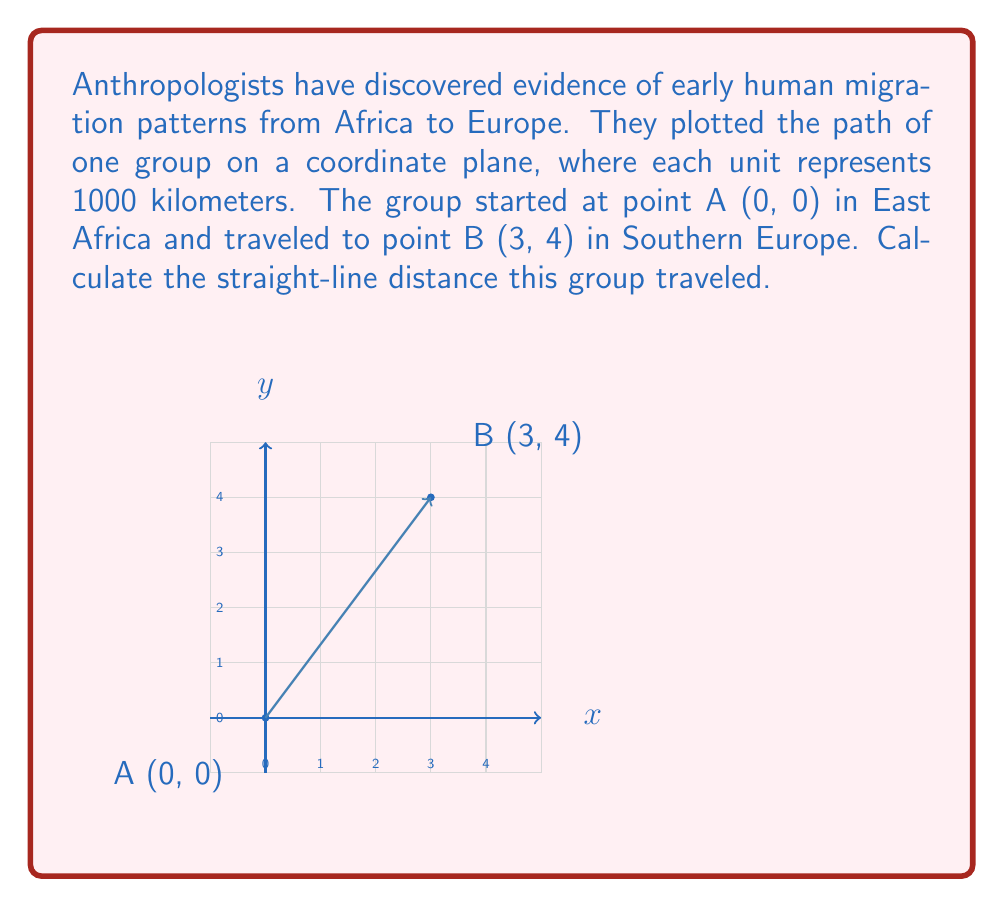Can you answer this question? To find the straight-line distance between two points on a coordinate plane, we can use the distance formula, which is derived from the Pythagorean theorem:

$$d = \sqrt{(x_2 - x_1)^2 + (y_2 - y_1)^2}$$

Where $(x_1, y_1)$ is the starting point and $(x_2, y_2)$ is the ending point.

Given:
- Starting point A: $(x_1, y_1) = (0, 0)$
- Ending point B: $(x_2, y_2) = (3, 4)$

Let's plug these values into the formula:

$$\begin{align}
d &= \sqrt{(x_2 - x_1)^2 + (y_2 - y_1)^2} \\
&= \sqrt{(3 - 0)^2 + (4 - 0)^2} \\
&= \sqrt{3^2 + 4^2} \\
&= \sqrt{9 + 16} \\
&= \sqrt{25} \\
&= 5
\end{align}$$

Therefore, the straight-line distance traveled is 5 units. Since each unit represents 1000 kilometers, the actual distance is 5000 kilometers.
Answer: 5000 kilometers 